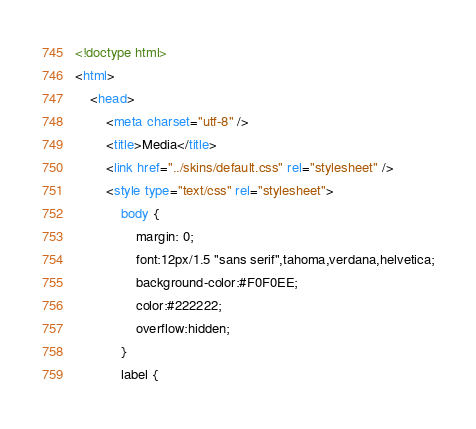Convert code to text. <code><loc_0><loc_0><loc_500><loc_500><_HTML_><!doctype html>
<html>
	<head>
		<meta charset="utf-8" />
		<title>Media</title>
		<link href="../skins/default.css" rel="stylesheet" />
		<style type="text/css" rel="stylesheet">
			body {
				margin: 0;
				font:12px/1.5 "sans serif",tahoma,verdana,helvetica;
				background-color:#F0F0EE;
				color:#222222;
				overflow:hidden;
			}
			label {</code> 